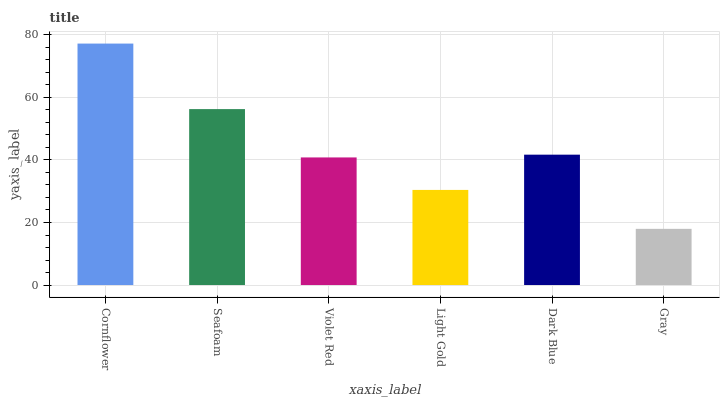Is Gray the minimum?
Answer yes or no. Yes. Is Cornflower the maximum?
Answer yes or no. Yes. Is Seafoam the minimum?
Answer yes or no. No. Is Seafoam the maximum?
Answer yes or no. No. Is Cornflower greater than Seafoam?
Answer yes or no. Yes. Is Seafoam less than Cornflower?
Answer yes or no. Yes. Is Seafoam greater than Cornflower?
Answer yes or no. No. Is Cornflower less than Seafoam?
Answer yes or no. No. Is Dark Blue the high median?
Answer yes or no. Yes. Is Violet Red the low median?
Answer yes or no. Yes. Is Gray the high median?
Answer yes or no. No. Is Cornflower the low median?
Answer yes or no. No. 